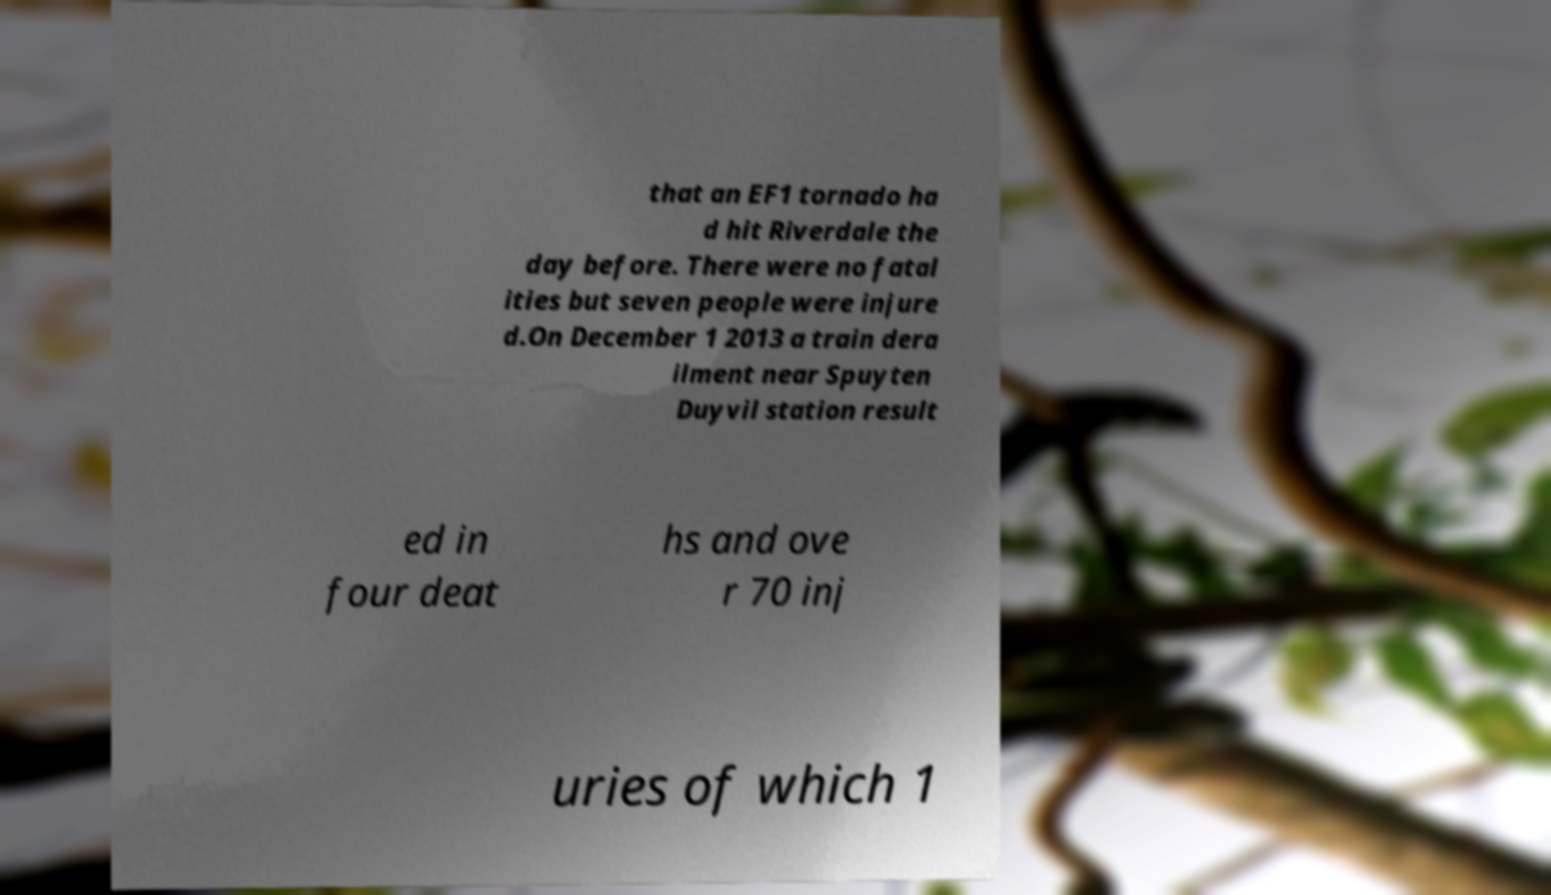What messages or text are displayed in this image? I need them in a readable, typed format. that an EF1 tornado ha d hit Riverdale the day before. There were no fatal ities but seven people were injure d.On December 1 2013 a train dera ilment near Spuyten Duyvil station result ed in four deat hs and ove r 70 inj uries of which 1 